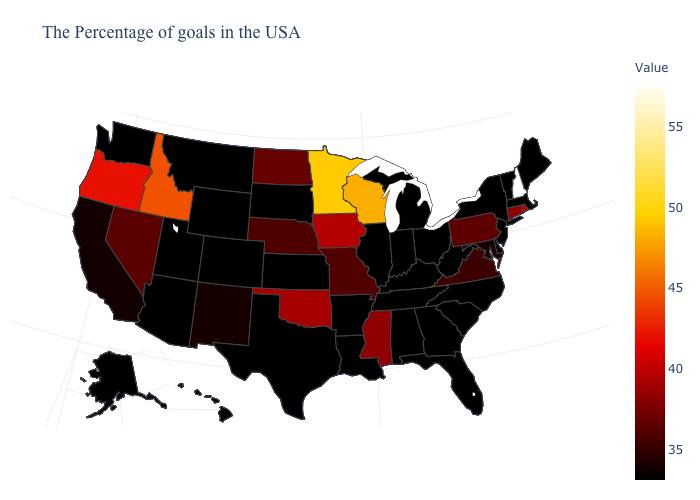Which states hav the highest value in the MidWest?
Concise answer only. Minnesota. Among the states that border Iowa , which have the lowest value?
Short answer required. Illinois, South Dakota. Does Illinois have the highest value in the MidWest?
Short answer required. No. Does North Carolina have the lowest value in the South?
Concise answer only. Yes. Does Maryland have the lowest value in the USA?
Keep it brief. No. Is the legend a continuous bar?
Quick response, please. Yes. Among the states that border North Carolina , which have the lowest value?
Give a very brief answer. South Carolina, Georgia, Tennessee. 